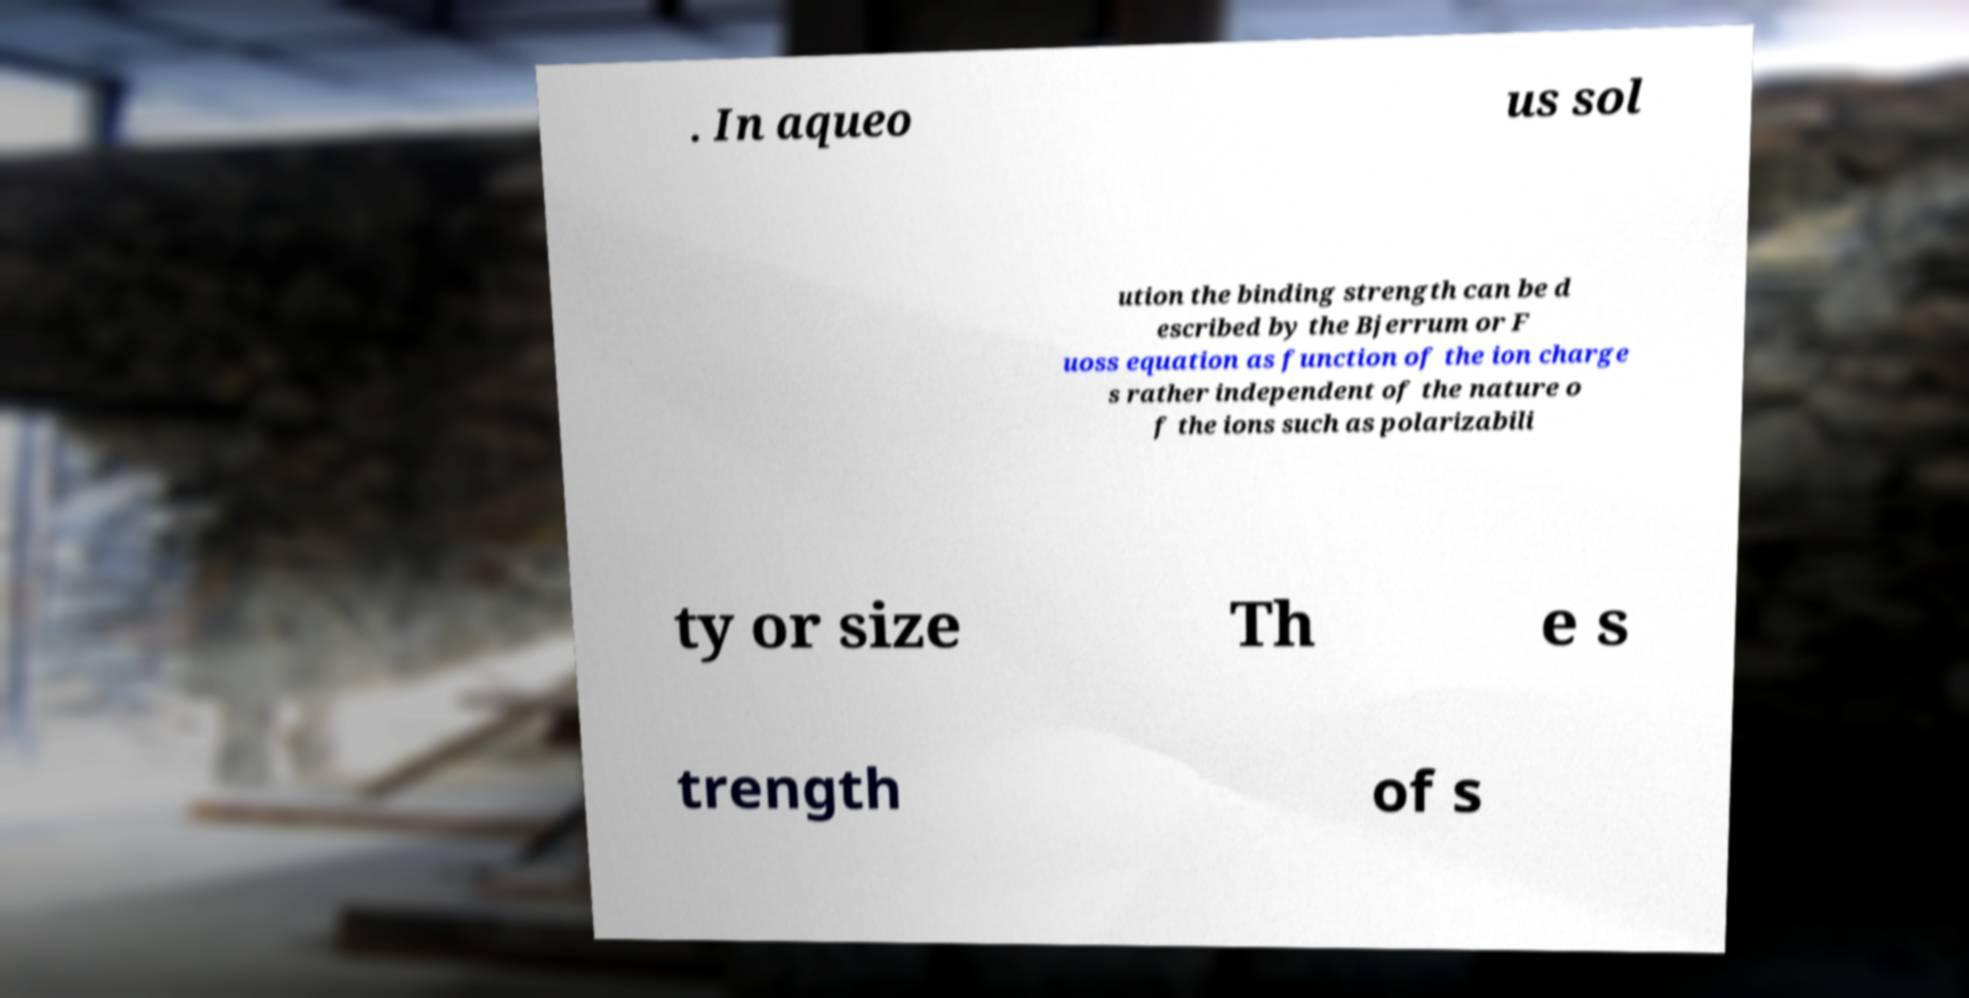I need the written content from this picture converted into text. Can you do that? . In aqueo us sol ution the binding strength can be d escribed by the Bjerrum or F uoss equation as function of the ion charge s rather independent of the nature o f the ions such as polarizabili ty or size Th e s trength of s 